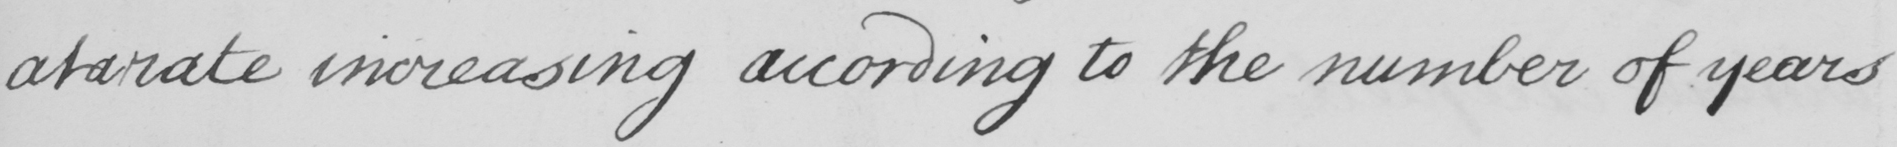Please transcribe the handwritten text in this image. at a rate increasing according to the number of years 